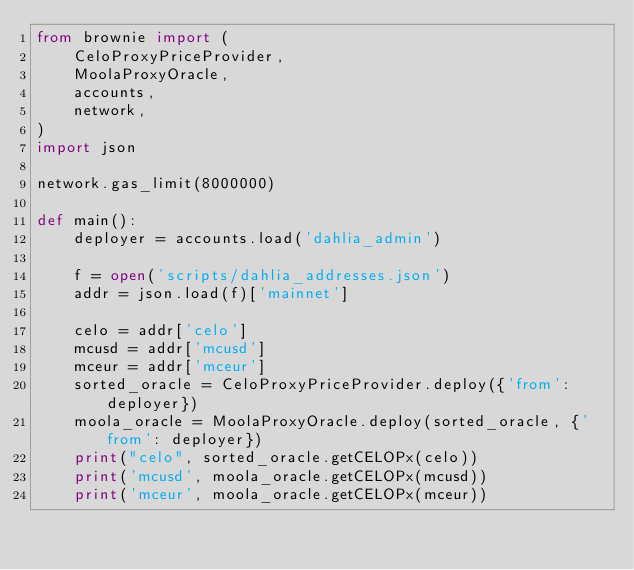<code> <loc_0><loc_0><loc_500><loc_500><_Python_>from brownie import (
    CeloProxyPriceProvider,
    MoolaProxyOracle,
    accounts,
    network,
)
import json

network.gas_limit(8000000)

def main():
    deployer = accounts.load('dahlia_admin')

    f = open('scripts/dahlia_addresses.json')
    addr = json.load(f)['mainnet']

    celo = addr['celo']
    mcusd = addr['mcusd']
    mceur = addr['mceur']
    sorted_oracle = CeloProxyPriceProvider.deploy({'from': deployer})
    moola_oracle = MoolaProxyOracle.deploy(sorted_oracle, {'from': deployer})
    print("celo", sorted_oracle.getCELOPx(celo))
    print('mcusd', moola_oracle.getCELOPx(mcusd))
    print('mceur', moola_oracle.getCELOPx(mceur))
</code> 